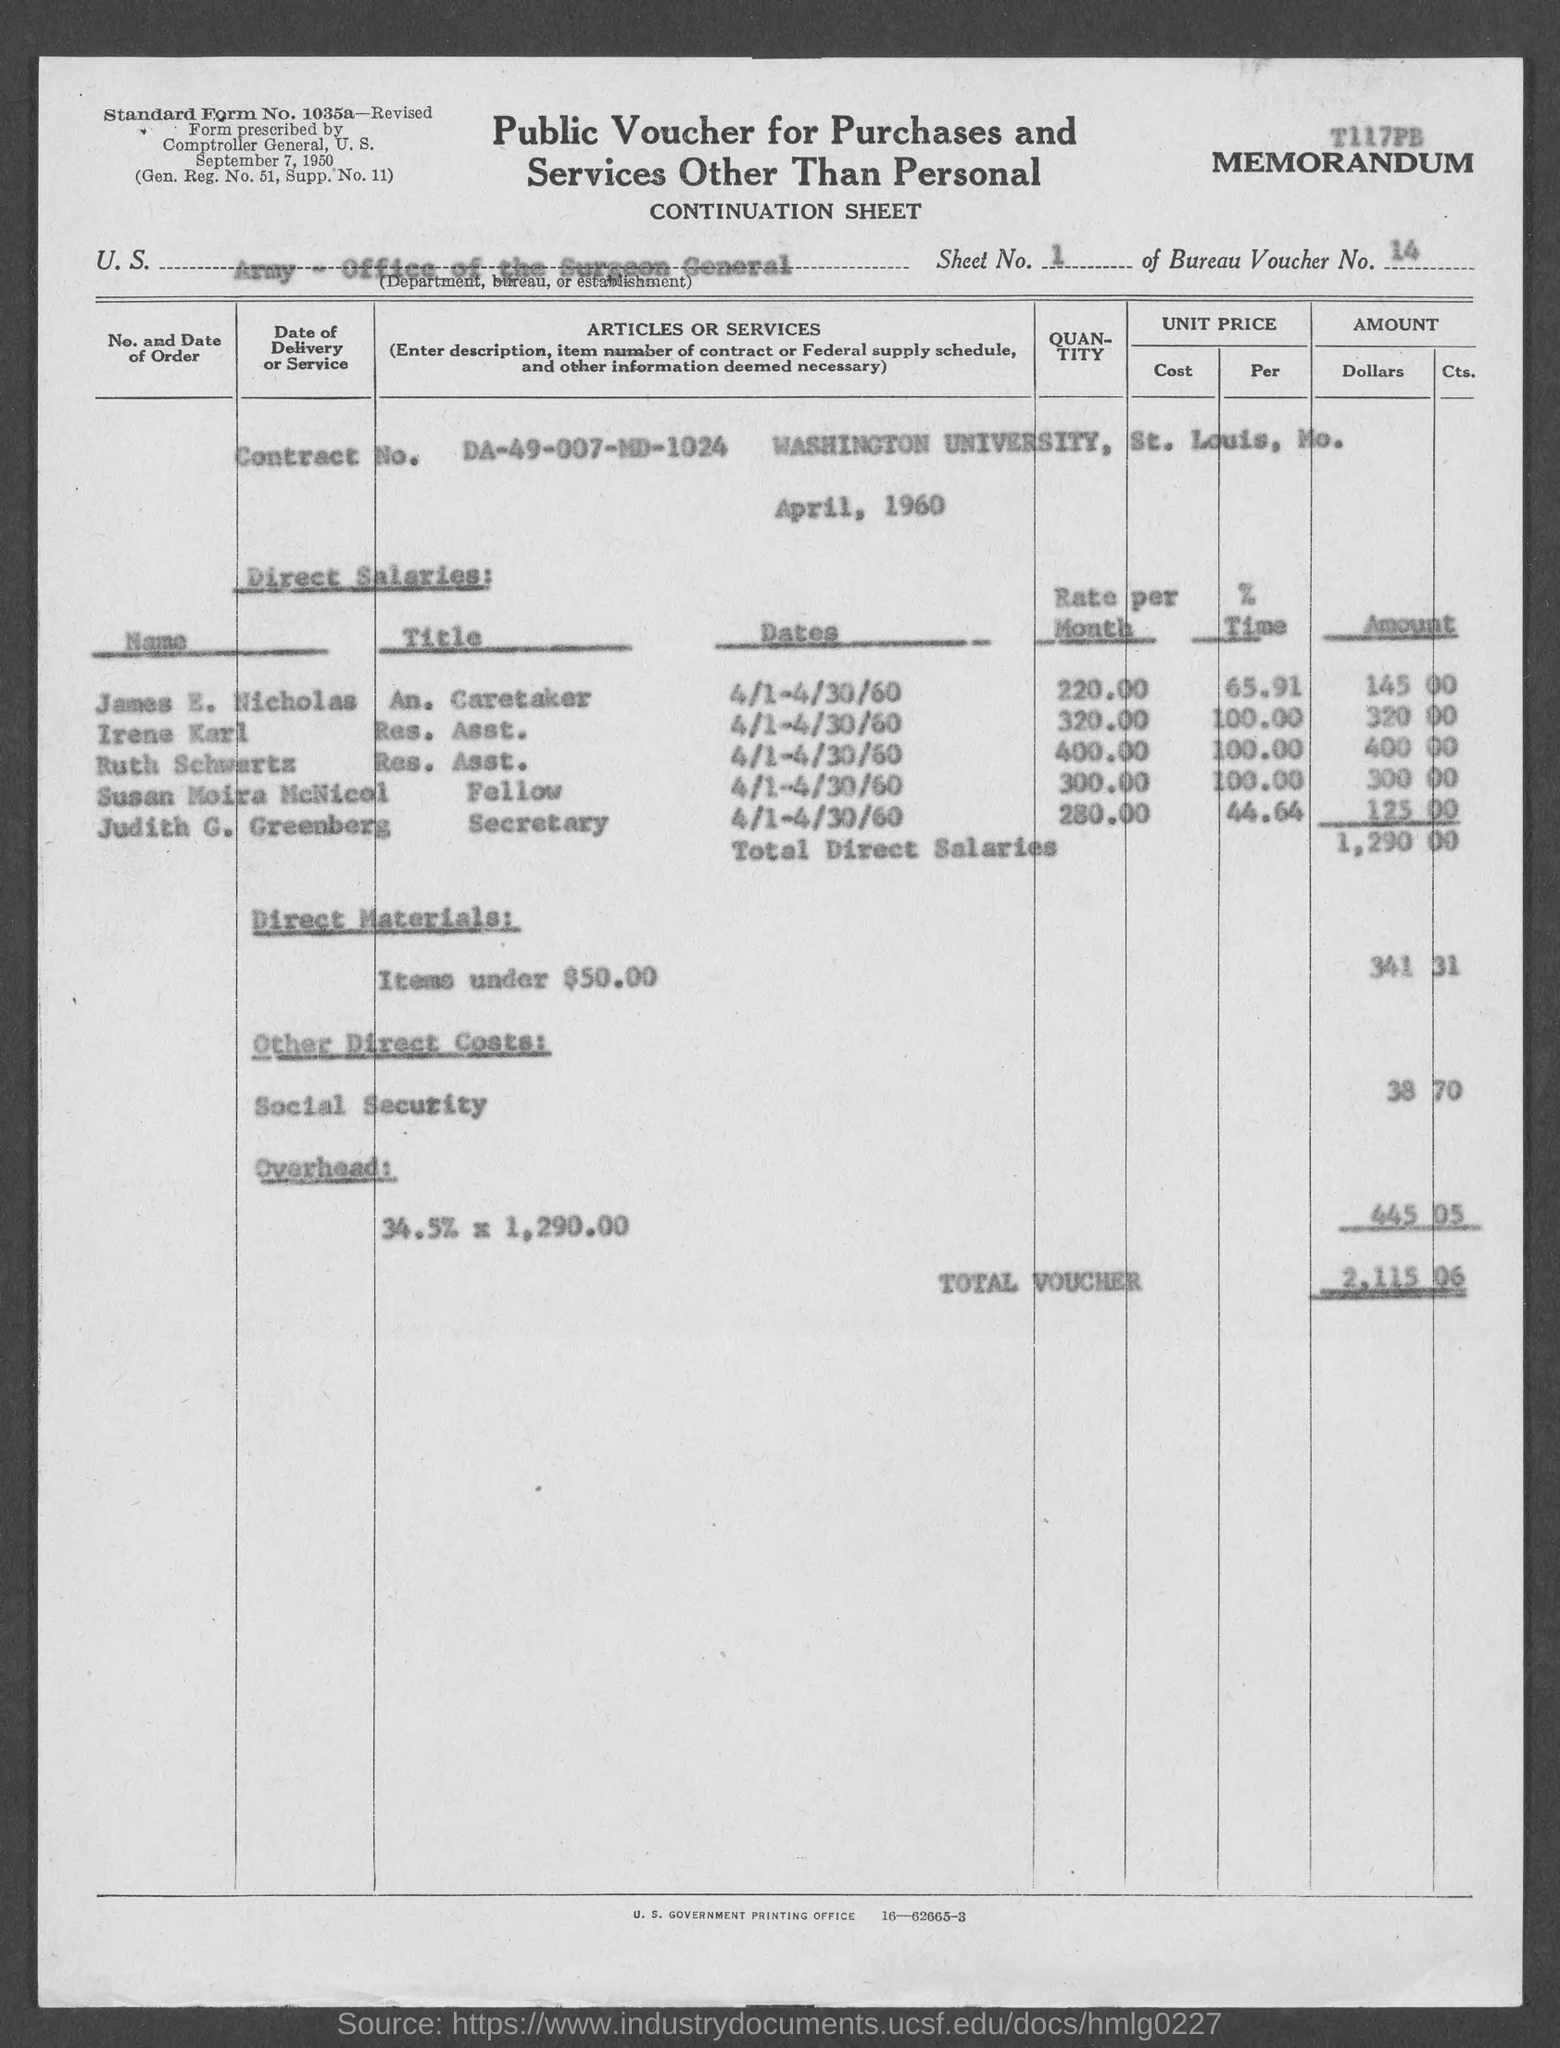What is the bureau voucher no.?
Make the answer very short. 14. 